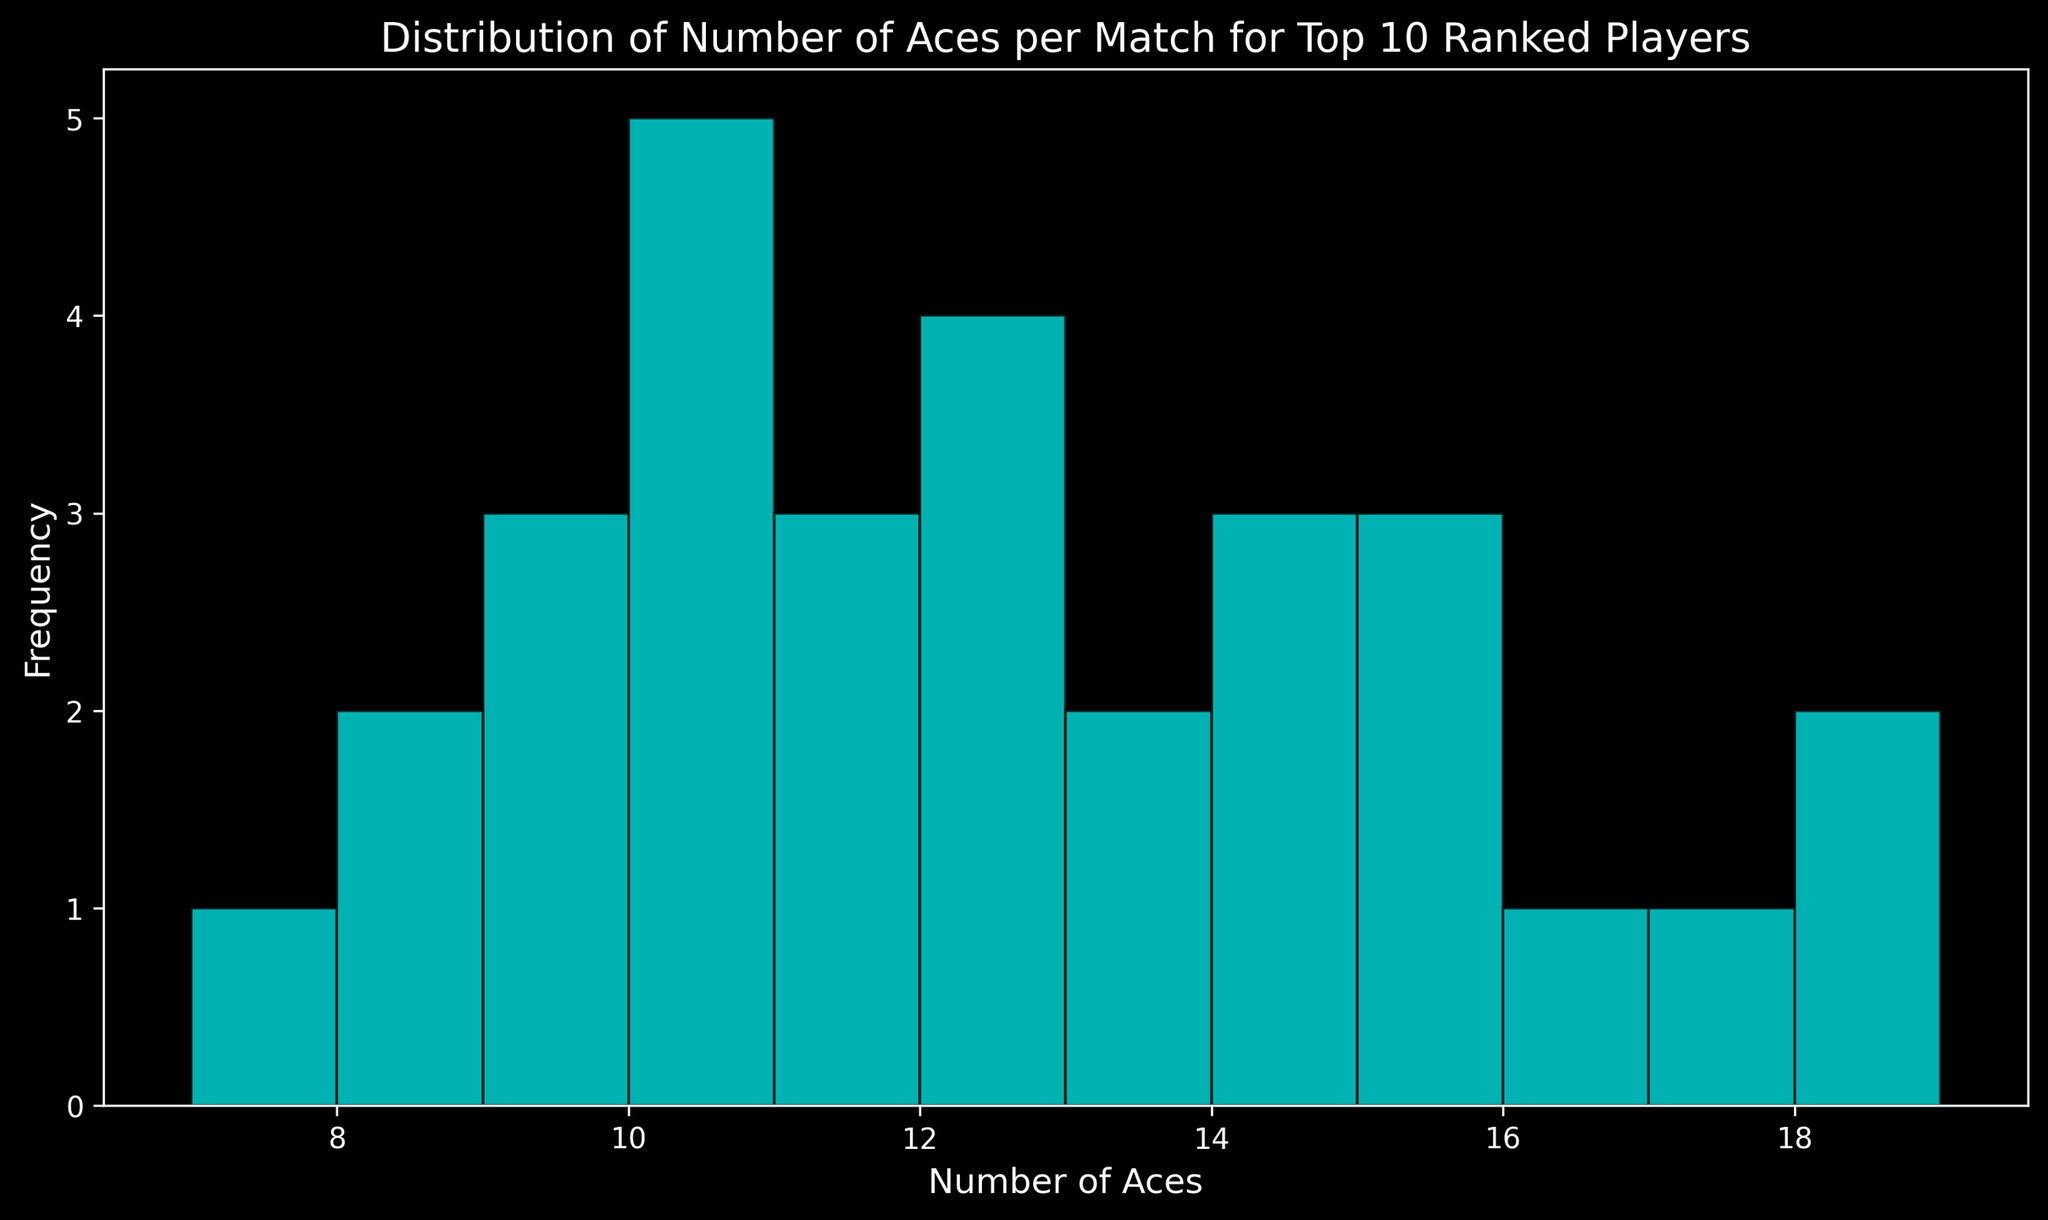How many total matches had exactly 10 aces? Count the frequency of the bar corresponding to 10 aces.
Answer: 5 Which number of aces per match is the most frequent? Identify the tallest bar in the histogram, which represents the mode of the distribution.
Answer: 10 What is the range of the number of aces per match? Subtract the smallest number of aces from the largest number shown in the histogram (Range = Max - Min).
Answer: 12 What is the average number of aces per match? Sum all the aces and divide by the total number of matches: (12+10+15+8+13+9+16+11+14+7+14+12+17+9+10+11+19+10+13+8+11+15+14+10+12+10+18+12+15+9)/30 = 12.
Answer: 12 How does the frequency of matches with 11 aces compare to those with 15 aces? Count and compare the bars for 11 and 15 aces in the histogram. Matches with 11 aces: 3, Matches with 15 aces: 3.
Answer: Equal Are there more matches with fewer than 10 aces or with exactly 10 aces? Count the frequency of matches with fewer than 10 aces (< 10) and compare it to the frequency of matches with exactly 10 aces. Fewer than 10: 9+8+7 occurrences, Exactly 10: 5 occurrences.
Answer: Fewer than 10 What is the frequency of the least common number of aces? Identify the shortest bar in the histogram and read its frequency.
Answer: 1 How many matches scored 12 or more aces? Sum the frequencies of bars representing 12 and more aces (12, 13, 14, 15, 16, 17, 18, 19).
Answer: 18 What is the difference in frequency between the number of matches with 12 aces and those with 19 aces? The frequency of matches with 12 aces is 3 and with 19 aces is 1, so the difference is 3 - 1.
Answer: 2 What could be inferred about the serving ability of top 10 players based on the histogram? Considering the distribution's central tendency, it suggests that top 10 players commonly hit around 10-12 aces per match, implying strong but not extremely divergent serving abilities among them.
Answer: Central tendency around 10-12 aces 